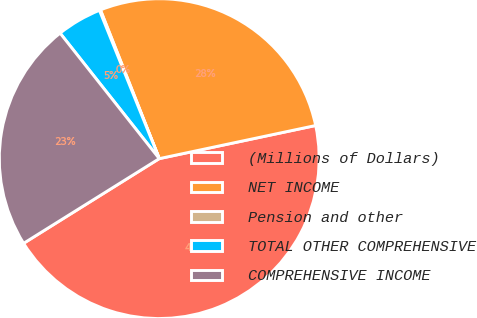<chart> <loc_0><loc_0><loc_500><loc_500><pie_chart><fcel>(Millions of Dollars)<fcel>NET INCOME<fcel>Pension and other<fcel>TOTAL OTHER COMPREHENSIVE<fcel>COMPREHENSIVE INCOME<nl><fcel>44.44%<fcel>27.67%<fcel>0.11%<fcel>4.54%<fcel>23.24%<nl></chart> 